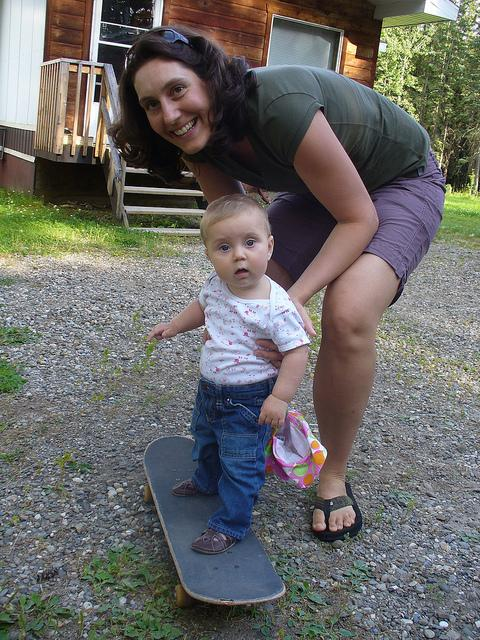What brand of sandals is the woman wearing? reef 